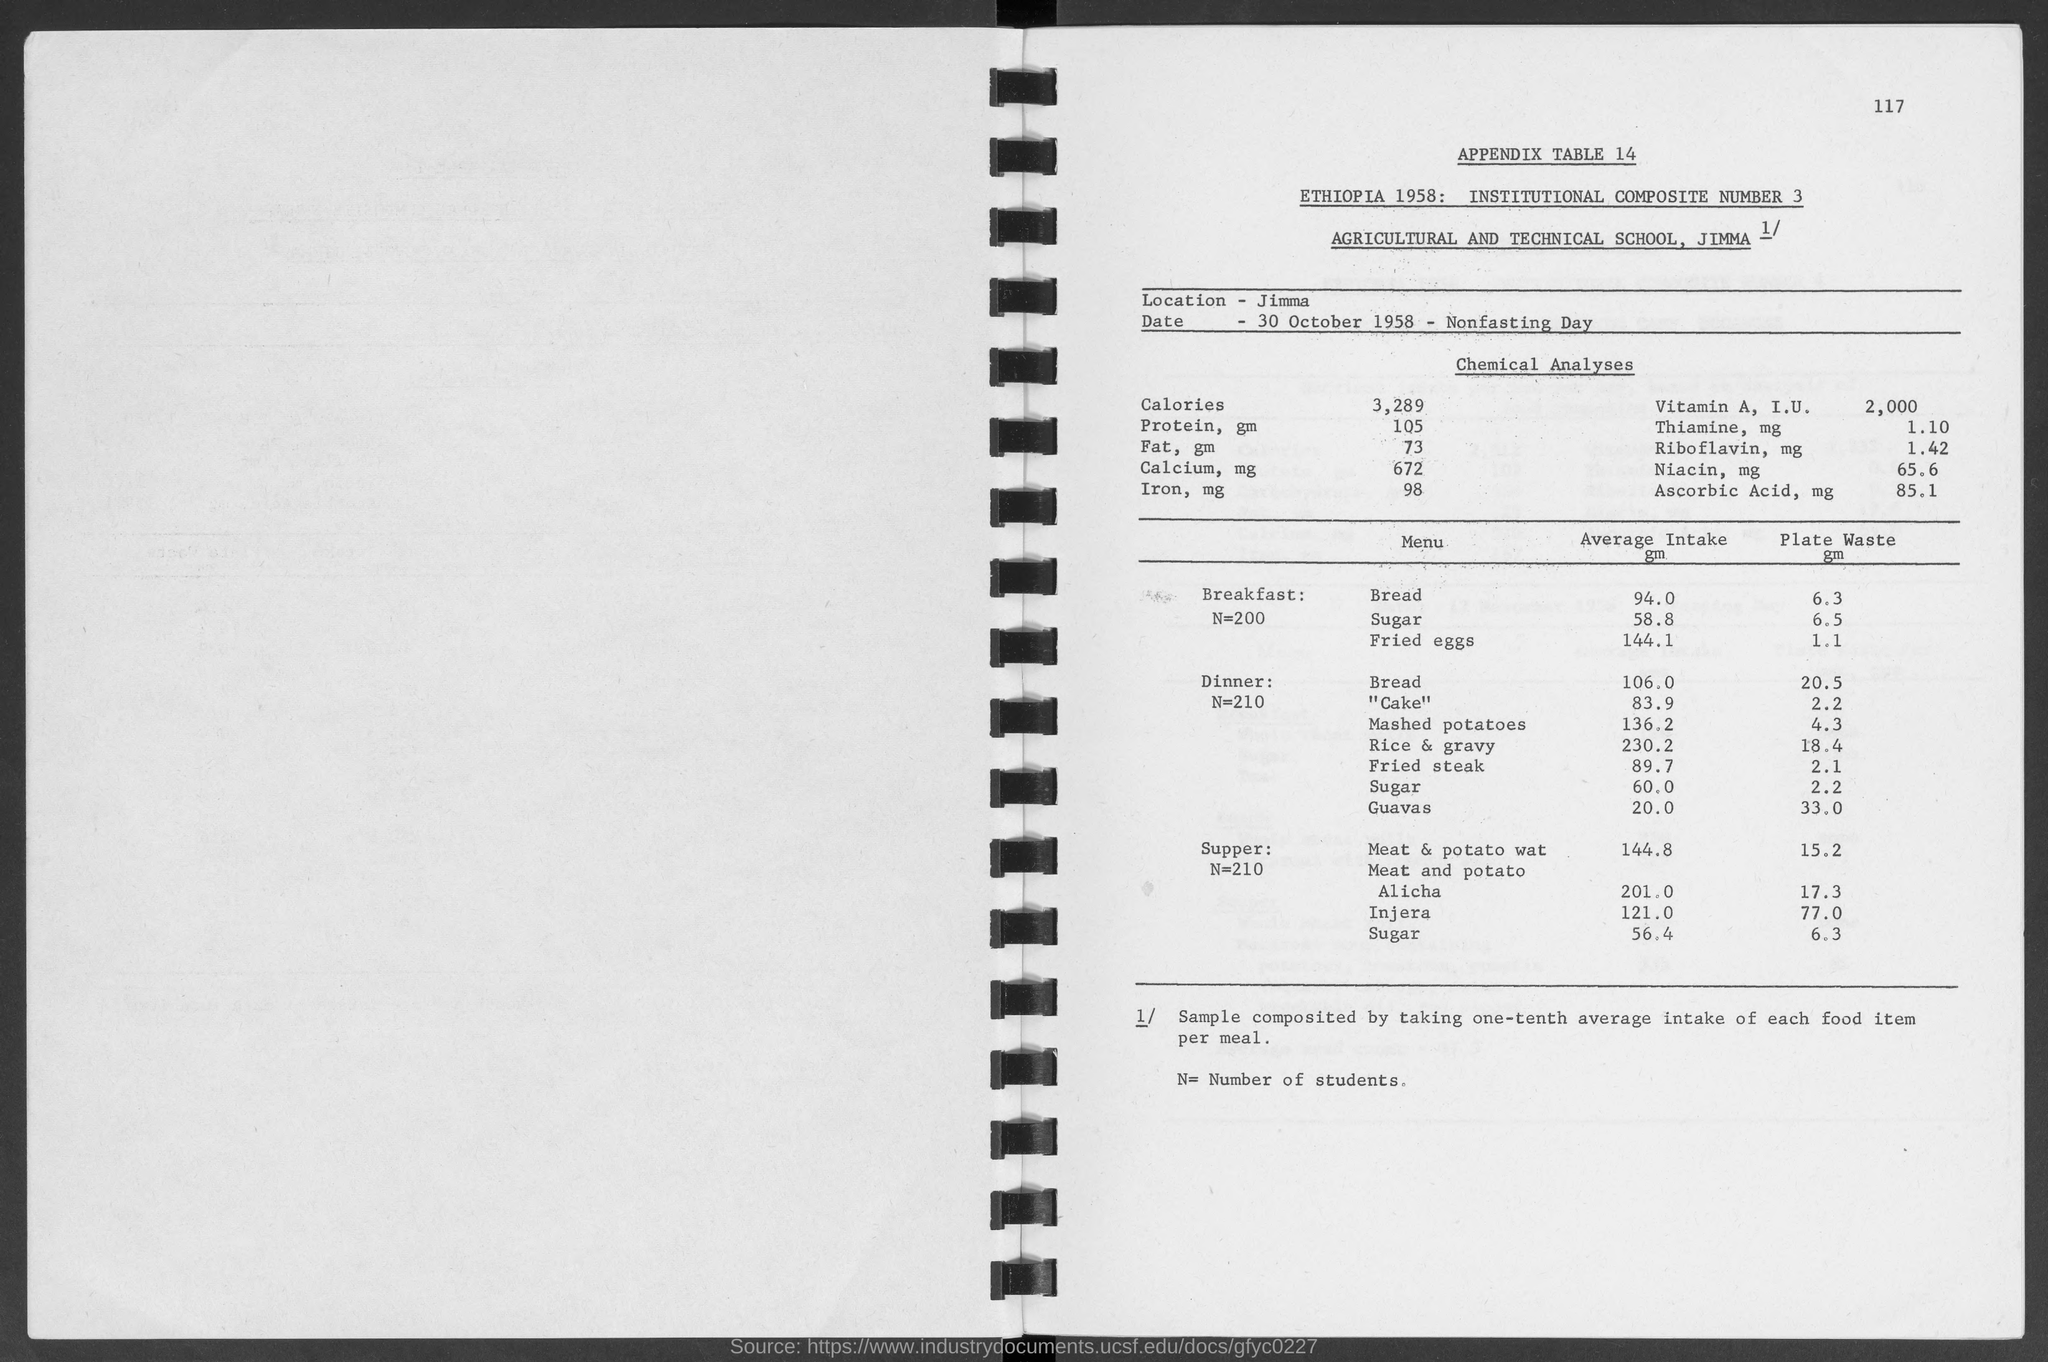Draw attention to some important aspects in this diagram. The average intake of bread in dinner is 106 grams. What is the appendix table number? The average consumption of cake during dinner is 83.9 units per person. On average, the average person consumes approximately 60 grams of sugar in their evening meal. The average intake of bread in breakfast is approximately 94%. 